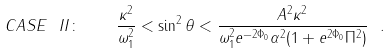<formula> <loc_0><loc_0><loc_500><loc_500>C A S E \ I I \colon \quad \frac { \kappa ^ { 2 } } { \omega _ { 1 } ^ { 2 } } < \sin ^ { 2 } \theta < \frac { A ^ { 2 } \kappa ^ { 2 } } { \omega _ { 1 } ^ { 2 } e ^ { - 2 \Phi _ { 0 } } \alpha ^ { 2 } ( 1 + e ^ { 2 \Phi _ { 0 } } \Pi ^ { 2 } ) } \ .</formula> 